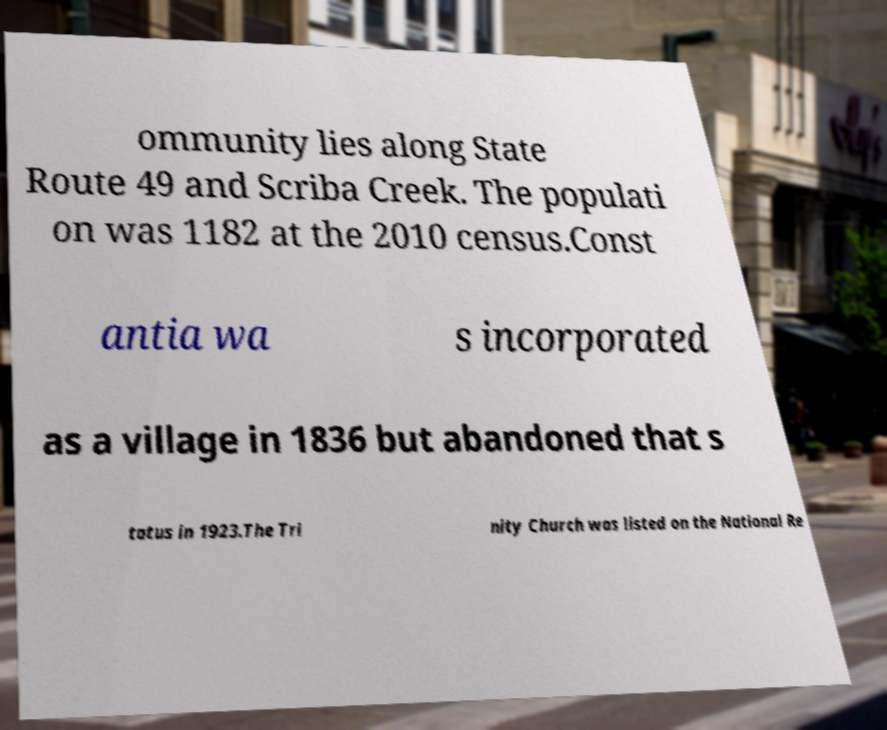Please read and relay the text visible in this image. What does it say? ommunity lies along State Route 49 and Scriba Creek. The populati on was 1182 at the 2010 census.Const antia wa s incorporated as a village in 1836 but abandoned that s tatus in 1923.The Tri nity Church was listed on the National Re 